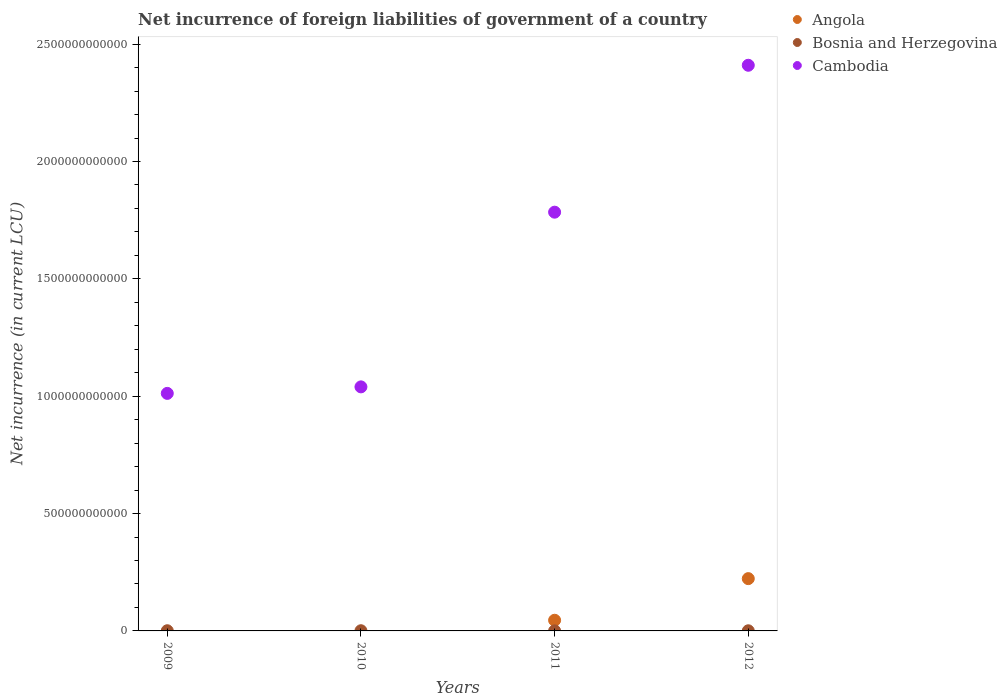How many different coloured dotlines are there?
Provide a short and direct response. 3. Is the number of dotlines equal to the number of legend labels?
Ensure brevity in your answer.  No. What is the net incurrence of foreign liabilities in Bosnia and Herzegovina in 2011?
Your response must be concise. 3.06e+08. Across all years, what is the maximum net incurrence of foreign liabilities in Bosnia and Herzegovina?
Your answer should be very brief. 8.00e+08. Across all years, what is the minimum net incurrence of foreign liabilities in Cambodia?
Offer a terse response. 1.01e+12. In which year was the net incurrence of foreign liabilities in Cambodia maximum?
Provide a succinct answer. 2012. What is the total net incurrence of foreign liabilities in Angola in the graph?
Provide a short and direct response. 2.68e+11. What is the difference between the net incurrence of foreign liabilities in Cambodia in 2010 and that in 2011?
Make the answer very short. -7.44e+11. What is the difference between the net incurrence of foreign liabilities in Angola in 2010 and the net incurrence of foreign liabilities in Cambodia in 2012?
Offer a very short reply. -2.41e+12. What is the average net incurrence of foreign liabilities in Cambodia per year?
Offer a very short reply. 1.56e+12. In the year 2011, what is the difference between the net incurrence of foreign liabilities in Cambodia and net incurrence of foreign liabilities in Bosnia and Herzegovina?
Provide a succinct answer. 1.78e+12. What is the ratio of the net incurrence of foreign liabilities in Bosnia and Herzegovina in 2011 to that in 2012?
Make the answer very short. 0.51. Is the difference between the net incurrence of foreign liabilities in Cambodia in 2010 and 2011 greater than the difference between the net incurrence of foreign liabilities in Bosnia and Herzegovina in 2010 and 2011?
Provide a short and direct response. No. What is the difference between the highest and the second highest net incurrence of foreign liabilities in Bosnia and Herzegovina?
Provide a succinct answer. 2.09e+07. What is the difference between the highest and the lowest net incurrence of foreign liabilities in Angola?
Provide a short and direct response. 2.23e+11. In how many years, is the net incurrence of foreign liabilities in Bosnia and Herzegovina greater than the average net incurrence of foreign liabilities in Bosnia and Herzegovina taken over all years?
Offer a very short reply. 2. Is the sum of the net incurrence of foreign liabilities in Angola in 2011 and 2012 greater than the maximum net incurrence of foreign liabilities in Bosnia and Herzegovina across all years?
Your response must be concise. Yes. Is it the case that in every year, the sum of the net incurrence of foreign liabilities in Angola and net incurrence of foreign liabilities in Cambodia  is greater than the net incurrence of foreign liabilities in Bosnia and Herzegovina?
Your answer should be compact. Yes. Is the net incurrence of foreign liabilities in Angola strictly greater than the net incurrence of foreign liabilities in Cambodia over the years?
Give a very brief answer. No. Is the net incurrence of foreign liabilities in Cambodia strictly less than the net incurrence of foreign liabilities in Bosnia and Herzegovina over the years?
Your answer should be very brief. No. How many dotlines are there?
Your answer should be very brief. 3. What is the difference between two consecutive major ticks on the Y-axis?
Give a very brief answer. 5.00e+11. How many legend labels are there?
Ensure brevity in your answer.  3. How are the legend labels stacked?
Give a very brief answer. Vertical. What is the title of the graph?
Your answer should be very brief. Net incurrence of foreign liabilities of government of a country. Does "American Samoa" appear as one of the legend labels in the graph?
Make the answer very short. No. What is the label or title of the Y-axis?
Your answer should be very brief. Net incurrence (in current LCU). What is the Net incurrence (in current LCU) of Bosnia and Herzegovina in 2009?
Provide a short and direct response. 7.79e+08. What is the Net incurrence (in current LCU) of Cambodia in 2009?
Offer a terse response. 1.01e+12. What is the Net incurrence (in current LCU) in Bosnia and Herzegovina in 2010?
Your response must be concise. 8.00e+08. What is the Net incurrence (in current LCU) of Cambodia in 2010?
Provide a short and direct response. 1.04e+12. What is the Net incurrence (in current LCU) in Angola in 2011?
Give a very brief answer. 4.54e+1. What is the Net incurrence (in current LCU) in Bosnia and Herzegovina in 2011?
Give a very brief answer. 3.06e+08. What is the Net incurrence (in current LCU) in Cambodia in 2011?
Keep it short and to the point. 1.78e+12. What is the Net incurrence (in current LCU) of Angola in 2012?
Make the answer very short. 2.23e+11. What is the Net incurrence (in current LCU) in Bosnia and Herzegovina in 2012?
Ensure brevity in your answer.  5.96e+08. What is the Net incurrence (in current LCU) of Cambodia in 2012?
Provide a short and direct response. 2.41e+12. Across all years, what is the maximum Net incurrence (in current LCU) in Angola?
Provide a short and direct response. 2.23e+11. Across all years, what is the maximum Net incurrence (in current LCU) in Bosnia and Herzegovina?
Your answer should be very brief. 8.00e+08. Across all years, what is the maximum Net incurrence (in current LCU) of Cambodia?
Provide a succinct answer. 2.41e+12. Across all years, what is the minimum Net incurrence (in current LCU) of Angola?
Your response must be concise. 0. Across all years, what is the minimum Net incurrence (in current LCU) in Bosnia and Herzegovina?
Your answer should be very brief. 3.06e+08. Across all years, what is the minimum Net incurrence (in current LCU) of Cambodia?
Your answer should be very brief. 1.01e+12. What is the total Net incurrence (in current LCU) in Angola in the graph?
Your answer should be compact. 2.68e+11. What is the total Net incurrence (in current LCU) of Bosnia and Herzegovina in the graph?
Keep it short and to the point. 2.48e+09. What is the total Net incurrence (in current LCU) of Cambodia in the graph?
Offer a terse response. 6.25e+12. What is the difference between the Net incurrence (in current LCU) in Bosnia and Herzegovina in 2009 and that in 2010?
Keep it short and to the point. -2.09e+07. What is the difference between the Net incurrence (in current LCU) in Cambodia in 2009 and that in 2010?
Give a very brief answer. -2.77e+1. What is the difference between the Net incurrence (in current LCU) in Bosnia and Herzegovina in 2009 and that in 2011?
Your response must be concise. 4.73e+08. What is the difference between the Net incurrence (in current LCU) in Cambodia in 2009 and that in 2011?
Provide a short and direct response. -7.72e+11. What is the difference between the Net incurrence (in current LCU) in Bosnia and Herzegovina in 2009 and that in 2012?
Provide a short and direct response. 1.84e+08. What is the difference between the Net incurrence (in current LCU) of Cambodia in 2009 and that in 2012?
Make the answer very short. -1.40e+12. What is the difference between the Net incurrence (in current LCU) in Bosnia and Herzegovina in 2010 and that in 2011?
Provide a short and direct response. 4.94e+08. What is the difference between the Net incurrence (in current LCU) in Cambodia in 2010 and that in 2011?
Make the answer very short. -7.44e+11. What is the difference between the Net incurrence (in current LCU) in Bosnia and Herzegovina in 2010 and that in 2012?
Provide a short and direct response. 2.05e+08. What is the difference between the Net incurrence (in current LCU) of Cambodia in 2010 and that in 2012?
Provide a short and direct response. -1.37e+12. What is the difference between the Net incurrence (in current LCU) in Angola in 2011 and that in 2012?
Offer a terse response. -1.77e+11. What is the difference between the Net incurrence (in current LCU) in Bosnia and Herzegovina in 2011 and that in 2012?
Make the answer very short. -2.89e+08. What is the difference between the Net incurrence (in current LCU) in Cambodia in 2011 and that in 2012?
Ensure brevity in your answer.  -6.26e+11. What is the difference between the Net incurrence (in current LCU) of Bosnia and Herzegovina in 2009 and the Net incurrence (in current LCU) of Cambodia in 2010?
Provide a short and direct response. -1.04e+12. What is the difference between the Net incurrence (in current LCU) of Bosnia and Herzegovina in 2009 and the Net incurrence (in current LCU) of Cambodia in 2011?
Provide a succinct answer. -1.78e+12. What is the difference between the Net incurrence (in current LCU) in Bosnia and Herzegovina in 2009 and the Net incurrence (in current LCU) in Cambodia in 2012?
Provide a succinct answer. -2.41e+12. What is the difference between the Net incurrence (in current LCU) in Bosnia and Herzegovina in 2010 and the Net incurrence (in current LCU) in Cambodia in 2011?
Offer a terse response. -1.78e+12. What is the difference between the Net incurrence (in current LCU) in Bosnia and Herzegovina in 2010 and the Net incurrence (in current LCU) in Cambodia in 2012?
Ensure brevity in your answer.  -2.41e+12. What is the difference between the Net incurrence (in current LCU) of Angola in 2011 and the Net incurrence (in current LCU) of Bosnia and Herzegovina in 2012?
Ensure brevity in your answer.  4.48e+1. What is the difference between the Net incurrence (in current LCU) of Angola in 2011 and the Net incurrence (in current LCU) of Cambodia in 2012?
Make the answer very short. -2.36e+12. What is the difference between the Net incurrence (in current LCU) in Bosnia and Herzegovina in 2011 and the Net incurrence (in current LCU) in Cambodia in 2012?
Keep it short and to the point. -2.41e+12. What is the average Net incurrence (in current LCU) in Angola per year?
Provide a succinct answer. 6.71e+1. What is the average Net incurrence (in current LCU) in Bosnia and Herzegovina per year?
Your answer should be compact. 6.20e+08. What is the average Net incurrence (in current LCU) in Cambodia per year?
Your answer should be compact. 1.56e+12. In the year 2009, what is the difference between the Net incurrence (in current LCU) of Bosnia and Herzegovina and Net incurrence (in current LCU) of Cambodia?
Offer a terse response. -1.01e+12. In the year 2010, what is the difference between the Net incurrence (in current LCU) in Bosnia and Herzegovina and Net incurrence (in current LCU) in Cambodia?
Provide a short and direct response. -1.04e+12. In the year 2011, what is the difference between the Net incurrence (in current LCU) of Angola and Net incurrence (in current LCU) of Bosnia and Herzegovina?
Keep it short and to the point. 4.51e+1. In the year 2011, what is the difference between the Net incurrence (in current LCU) in Angola and Net incurrence (in current LCU) in Cambodia?
Make the answer very short. -1.74e+12. In the year 2011, what is the difference between the Net incurrence (in current LCU) in Bosnia and Herzegovina and Net incurrence (in current LCU) in Cambodia?
Your answer should be compact. -1.78e+12. In the year 2012, what is the difference between the Net incurrence (in current LCU) of Angola and Net incurrence (in current LCU) of Bosnia and Herzegovina?
Provide a short and direct response. 2.22e+11. In the year 2012, what is the difference between the Net incurrence (in current LCU) in Angola and Net incurrence (in current LCU) in Cambodia?
Provide a succinct answer. -2.19e+12. In the year 2012, what is the difference between the Net incurrence (in current LCU) in Bosnia and Herzegovina and Net incurrence (in current LCU) in Cambodia?
Ensure brevity in your answer.  -2.41e+12. What is the ratio of the Net incurrence (in current LCU) in Bosnia and Herzegovina in 2009 to that in 2010?
Your answer should be very brief. 0.97. What is the ratio of the Net incurrence (in current LCU) of Cambodia in 2009 to that in 2010?
Your answer should be very brief. 0.97. What is the ratio of the Net incurrence (in current LCU) in Bosnia and Herzegovina in 2009 to that in 2011?
Your answer should be very brief. 2.55. What is the ratio of the Net incurrence (in current LCU) in Cambodia in 2009 to that in 2011?
Provide a short and direct response. 0.57. What is the ratio of the Net incurrence (in current LCU) of Bosnia and Herzegovina in 2009 to that in 2012?
Make the answer very short. 1.31. What is the ratio of the Net incurrence (in current LCU) in Cambodia in 2009 to that in 2012?
Make the answer very short. 0.42. What is the ratio of the Net incurrence (in current LCU) of Bosnia and Herzegovina in 2010 to that in 2011?
Keep it short and to the point. 2.61. What is the ratio of the Net incurrence (in current LCU) in Cambodia in 2010 to that in 2011?
Make the answer very short. 0.58. What is the ratio of the Net incurrence (in current LCU) of Bosnia and Herzegovina in 2010 to that in 2012?
Your answer should be very brief. 1.34. What is the ratio of the Net incurrence (in current LCU) of Cambodia in 2010 to that in 2012?
Ensure brevity in your answer.  0.43. What is the ratio of the Net incurrence (in current LCU) of Angola in 2011 to that in 2012?
Provide a short and direct response. 0.2. What is the ratio of the Net incurrence (in current LCU) in Bosnia and Herzegovina in 2011 to that in 2012?
Make the answer very short. 0.51. What is the ratio of the Net incurrence (in current LCU) of Cambodia in 2011 to that in 2012?
Offer a terse response. 0.74. What is the difference between the highest and the second highest Net incurrence (in current LCU) of Bosnia and Herzegovina?
Offer a terse response. 2.09e+07. What is the difference between the highest and the second highest Net incurrence (in current LCU) of Cambodia?
Your response must be concise. 6.26e+11. What is the difference between the highest and the lowest Net incurrence (in current LCU) of Angola?
Offer a terse response. 2.23e+11. What is the difference between the highest and the lowest Net incurrence (in current LCU) in Bosnia and Herzegovina?
Provide a succinct answer. 4.94e+08. What is the difference between the highest and the lowest Net incurrence (in current LCU) of Cambodia?
Your response must be concise. 1.40e+12. 